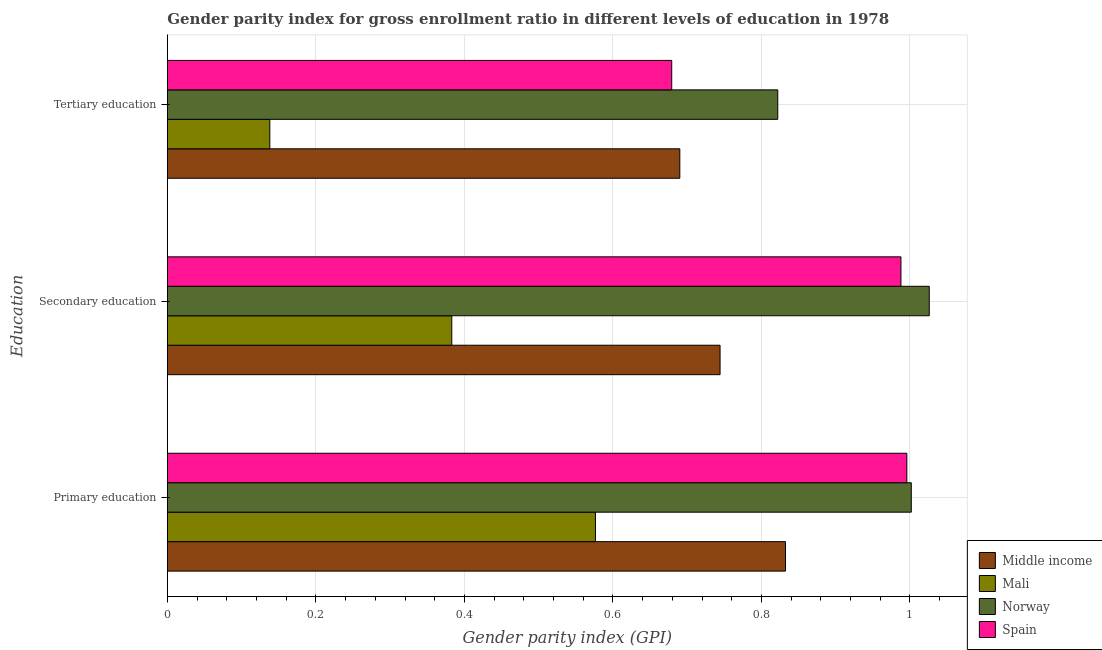How many different coloured bars are there?
Offer a very short reply. 4. Are the number of bars per tick equal to the number of legend labels?
Your answer should be compact. Yes. How many bars are there on the 3rd tick from the bottom?
Keep it short and to the point. 4. What is the label of the 3rd group of bars from the top?
Make the answer very short. Primary education. What is the gender parity index in primary education in Mali?
Your answer should be very brief. 0.58. Across all countries, what is the maximum gender parity index in tertiary education?
Your answer should be compact. 0.82. Across all countries, what is the minimum gender parity index in secondary education?
Ensure brevity in your answer.  0.38. In which country was the gender parity index in secondary education minimum?
Offer a terse response. Mali. What is the total gender parity index in secondary education in the graph?
Provide a short and direct response. 3.14. What is the difference between the gender parity index in primary education in Mali and that in Middle income?
Your answer should be very brief. -0.26. What is the difference between the gender parity index in tertiary education in Spain and the gender parity index in primary education in Middle income?
Offer a very short reply. -0.15. What is the average gender parity index in tertiary education per country?
Give a very brief answer. 0.58. What is the difference between the gender parity index in secondary education and gender parity index in tertiary education in Middle income?
Give a very brief answer. 0.05. What is the ratio of the gender parity index in secondary education in Spain to that in Middle income?
Your response must be concise. 1.33. Is the gender parity index in secondary education in Norway less than that in Middle income?
Provide a short and direct response. No. Is the difference between the gender parity index in secondary education in Middle income and Spain greater than the difference between the gender parity index in tertiary education in Middle income and Spain?
Offer a terse response. No. What is the difference between the highest and the second highest gender parity index in tertiary education?
Offer a very short reply. 0.13. What is the difference between the highest and the lowest gender parity index in primary education?
Provide a succinct answer. 0.43. In how many countries, is the gender parity index in secondary education greater than the average gender parity index in secondary education taken over all countries?
Give a very brief answer. 2. Is the sum of the gender parity index in primary education in Mali and Norway greater than the maximum gender parity index in secondary education across all countries?
Your answer should be very brief. Yes. What does the 1st bar from the bottom in Tertiary education represents?
Your answer should be very brief. Middle income. How many countries are there in the graph?
Your response must be concise. 4. Are the values on the major ticks of X-axis written in scientific E-notation?
Ensure brevity in your answer.  No. Does the graph contain any zero values?
Offer a terse response. No. How are the legend labels stacked?
Keep it short and to the point. Vertical. What is the title of the graph?
Offer a very short reply. Gender parity index for gross enrollment ratio in different levels of education in 1978. Does "American Samoa" appear as one of the legend labels in the graph?
Offer a very short reply. No. What is the label or title of the X-axis?
Provide a succinct answer. Gender parity index (GPI). What is the label or title of the Y-axis?
Provide a short and direct response. Education. What is the Gender parity index (GPI) in Middle income in Primary education?
Ensure brevity in your answer.  0.83. What is the Gender parity index (GPI) of Mali in Primary education?
Make the answer very short. 0.58. What is the Gender parity index (GPI) of Norway in Primary education?
Make the answer very short. 1. What is the Gender parity index (GPI) in Spain in Primary education?
Keep it short and to the point. 1. What is the Gender parity index (GPI) in Middle income in Secondary education?
Your response must be concise. 0.74. What is the Gender parity index (GPI) of Mali in Secondary education?
Provide a succinct answer. 0.38. What is the Gender parity index (GPI) in Norway in Secondary education?
Provide a short and direct response. 1.03. What is the Gender parity index (GPI) in Spain in Secondary education?
Offer a terse response. 0.99. What is the Gender parity index (GPI) of Middle income in Tertiary education?
Offer a very short reply. 0.69. What is the Gender parity index (GPI) of Mali in Tertiary education?
Your answer should be compact. 0.14. What is the Gender parity index (GPI) of Norway in Tertiary education?
Provide a short and direct response. 0.82. What is the Gender parity index (GPI) in Spain in Tertiary education?
Your answer should be very brief. 0.68. Across all Education, what is the maximum Gender parity index (GPI) in Middle income?
Offer a terse response. 0.83. Across all Education, what is the maximum Gender parity index (GPI) of Mali?
Offer a very short reply. 0.58. Across all Education, what is the maximum Gender parity index (GPI) in Norway?
Offer a terse response. 1.03. Across all Education, what is the maximum Gender parity index (GPI) of Spain?
Your answer should be compact. 1. Across all Education, what is the minimum Gender parity index (GPI) in Middle income?
Offer a terse response. 0.69. Across all Education, what is the minimum Gender parity index (GPI) of Mali?
Your answer should be compact. 0.14. Across all Education, what is the minimum Gender parity index (GPI) in Norway?
Provide a succinct answer. 0.82. Across all Education, what is the minimum Gender parity index (GPI) in Spain?
Make the answer very short. 0.68. What is the total Gender parity index (GPI) of Middle income in the graph?
Offer a very short reply. 2.27. What is the total Gender parity index (GPI) of Mali in the graph?
Provide a short and direct response. 1.1. What is the total Gender parity index (GPI) of Norway in the graph?
Offer a terse response. 2.85. What is the total Gender parity index (GPI) in Spain in the graph?
Your response must be concise. 2.66. What is the difference between the Gender parity index (GPI) in Middle income in Primary education and that in Secondary education?
Give a very brief answer. 0.09. What is the difference between the Gender parity index (GPI) in Mali in Primary education and that in Secondary education?
Your answer should be compact. 0.19. What is the difference between the Gender parity index (GPI) in Norway in Primary education and that in Secondary education?
Your response must be concise. -0.02. What is the difference between the Gender parity index (GPI) in Spain in Primary education and that in Secondary education?
Offer a terse response. 0.01. What is the difference between the Gender parity index (GPI) of Middle income in Primary education and that in Tertiary education?
Your response must be concise. 0.14. What is the difference between the Gender parity index (GPI) of Mali in Primary education and that in Tertiary education?
Offer a terse response. 0.44. What is the difference between the Gender parity index (GPI) of Norway in Primary education and that in Tertiary education?
Offer a very short reply. 0.18. What is the difference between the Gender parity index (GPI) of Spain in Primary education and that in Tertiary education?
Keep it short and to the point. 0.32. What is the difference between the Gender parity index (GPI) in Middle income in Secondary education and that in Tertiary education?
Offer a very short reply. 0.05. What is the difference between the Gender parity index (GPI) in Mali in Secondary education and that in Tertiary education?
Provide a succinct answer. 0.24. What is the difference between the Gender parity index (GPI) in Norway in Secondary education and that in Tertiary education?
Your response must be concise. 0.2. What is the difference between the Gender parity index (GPI) in Spain in Secondary education and that in Tertiary education?
Provide a short and direct response. 0.31. What is the difference between the Gender parity index (GPI) of Middle income in Primary education and the Gender parity index (GPI) of Mali in Secondary education?
Provide a short and direct response. 0.45. What is the difference between the Gender parity index (GPI) of Middle income in Primary education and the Gender parity index (GPI) of Norway in Secondary education?
Ensure brevity in your answer.  -0.19. What is the difference between the Gender parity index (GPI) of Middle income in Primary education and the Gender parity index (GPI) of Spain in Secondary education?
Give a very brief answer. -0.16. What is the difference between the Gender parity index (GPI) in Mali in Primary education and the Gender parity index (GPI) in Norway in Secondary education?
Offer a very short reply. -0.45. What is the difference between the Gender parity index (GPI) in Mali in Primary education and the Gender parity index (GPI) in Spain in Secondary education?
Your response must be concise. -0.41. What is the difference between the Gender parity index (GPI) in Norway in Primary education and the Gender parity index (GPI) in Spain in Secondary education?
Your answer should be compact. 0.01. What is the difference between the Gender parity index (GPI) of Middle income in Primary education and the Gender parity index (GPI) of Mali in Tertiary education?
Offer a very short reply. 0.69. What is the difference between the Gender parity index (GPI) of Middle income in Primary education and the Gender parity index (GPI) of Norway in Tertiary education?
Offer a terse response. 0.01. What is the difference between the Gender parity index (GPI) of Middle income in Primary education and the Gender parity index (GPI) of Spain in Tertiary education?
Your answer should be very brief. 0.15. What is the difference between the Gender parity index (GPI) of Mali in Primary education and the Gender parity index (GPI) of Norway in Tertiary education?
Make the answer very short. -0.25. What is the difference between the Gender parity index (GPI) in Mali in Primary education and the Gender parity index (GPI) in Spain in Tertiary education?
Ensure brevity in your answer.  -0.1. What is the difference between the Gender parity index (GPI) in Norway in Primary education and the Gender parity index (GPI) in Spain in Tertiary education?
Keep it short and to the point. 0.32. What is the difference between the Gender parity index (GPI) in Middle income in Secondary education and the Gender parity index (GPI) in Mali in Tertiary education?
Give a very brief answer. 0.61. What is the difference between the Gender parity index (GPI) in Middle income in Secondary education and the Gender parity index (GPI) in Norway in Tertiary education?
Offer a very short reply. -0.08. What is the difference between the Gender parity index (GPI) in Middle income in Secondary education and the Gender parity index (GPI) in Spain in Tertiary education?
Give a very brief answer. 0.07. What is the difference between the Gender parity index (GPI) of Mali in Secondary education and the Gender parity index (GPI) of Norway in Tertiary education?
Give a very brief answer. -0.44. What is the difference between the Gender parity index (GPI) of Mali in Secondary education and the Gender parity index (GPI) of Spain in Tertiary education?
Offer a very short reply. -0.3. What is the difference between the Gender parity index (GPI) of Norway in Secondary education and the Gender parity index (GPI) of Spain in Tertiary education?
Offer a terse response. 0.35. What is the average Gender parity index (GPI) in Middle income per Education?
Offer a terse response. 0.76. What is the average Gender parity index (GPI) in Mali per Education?
Make the answer very short. 0.37. What is the average Gender parity index (GPI) of Norway per Education?
Ensure brevity in your answer.  0.95. What is the average Gender parity index (GPI) in Spain per Education?
Your answer should be compact. 0.89. What is the difference between the Gender parity index (GPI) in Middle income and Gender parity index (GPI) in Mali in Primary education?
Your answer should be compact. 0.26. What is the difference between the Gender parity index (GPI) in Middle income and Gender parity index (GPI) in Norway in Primary education?
Your answer should be very brief. -0.17. What is the difference between the Gender parity index (GPI) in Middle income and Gender parity index (GPI) in Spain in Primary education?
Keep it short and to the point. -0.16. What is the difference between the Gender parity index (GPI) of Mali and Gender parity index (GPI) of Norway in Primary education?
Offer a terse response. -0.43. What is the difference between the Gender parity index (GPI) in Mali and Gender parity index (GPI) in Spain in Primary education?
Provide a short and direct response. -0.42. What is the difference between the Gender parity index (GPI) in Norway and Gender parity index (GPI) in Spain in Primary education?
Make the answer very short. 0.01. What is the difference between the Gender parity index (GPI) in Middle income and Gender parity index (GPI) in Mali in Secondary education?
Your answer should be compact. 0.36. What is the difference between the Gender parity index (GPI) of Middle income and Gender parity index (GPI) of Norway in Secondary education?
Your answer should be very brief. -0.28. What is the difference between the Gender parity index (GPI) of Middle income and Gender parity index (GPI) of Spain in Secondary education?
Your answer should be compact. -0.24. What is the difference between the Gender parity index (GPI) in Mali and Gender parity index (GPI) in Norway in Secondary education?
Your answer should be compact. -0.64. What is the difference between the Gender parity index (GPI) of Mali and Gender parity index (GPI) of Spain in Secondary education?
Your answer should be compact. -0.6. What is the difference between the Gender parity index (GPI) of Norway and Gender parity index (GPI) of Spain in Secondary education?
Provide a succinct answer. 0.04. What is the difference between the Gender parity index (GPI) of Middle income and Gender parity index (GPI) of Mali in Tertiary education?
Keep it short and to the point. 0.55. What is the difference between the Gender parity index (GPI) in Middle income and Gender parity index (GPI) in Norway in Tertiary education?
Provide a short and direct response. -0.13. What is the difference between the Gender parity index (GPI) in Middle income and Gender parity index (GPI) in Spain in Tertiary education?
Your answer should be very brief. 0.01. What is the difference between the Gender parity index (GPI) in Mali and Gender parity index (GPI) in Norway in Tertiary education?
Ensure brevity in your answer.  -0.68. What is the difference between the Gender parity index (GPI) of Mali and Gender parity index (GPI) of Spain in Tertiary education?
Your answer should be very brief. -0.54. What is the difference between the Gender parity index (GPI) of Norway and Gender parity index (GPI) of Spain in Tertiary education?
Provide a short and direct response. 0.14. What is the ratio of the Gender parity index (GPI) of Middle income in Primary education to that in Secondary education?
Offer a very short reply. 1.12. What is the ratio of the Gender parity index (GPI) in Mali in Primary education to that in Secondary education?
Offer a terse response. 1.51. What is the ratio of the Gender parity index (GPI) in Norway in Primary education to that in Secondary education?
Keep it short and to the point. 0.98. What is the ratio of the Gender parity index (GPI) in Spain in Primary education to that in Secondary education?
Offer a very short reply. 1.01. What is the ratio of the Gender parity index (GPI) in Middle income in Primary education to that in Tertiary education?
Give a very brief answer. 1.21. What is the ratio of the Gender parity index (GPI) of Mali in Primary education to that in Tertiary education?
Your answer should be compact. 4.18. What is the ratio of the Gender parity index (GPI) in Norway in Primary education to that in Tertiary education?
Make the answer very short. 1.22. What is the ratio of the Gender parity index (GPI) in Spain in Primary education to that in Tertiary education?
Your answer should be compact. 1.47. What is the ratio of the Gender parity index (GPI) of Middle income in Secondary education to that in Tertiary education?
Offer a very short reply. 1.08. What is the ratio of the Gender parity index (GPI) in Mali in Secondary education to that in Tertiary education?
Make the answer very short. 2.78. What is the ratio of the Gender parity index (GPI) in Norway in Secondary education to that in Tertiary education?
Provide a succinct answer. 1.25. What is the ratio of the Gender parity index (GPI) of Spain in Secondary education to that in Tertiary education?
Provide a short and direct response. 1.45. What is the difference between the highest and the second highest Gender parity index (GPI) in Middle income?
Ensure brevity in your answer.  0.09. What is the difference between the highest and the second highest Gender parity index (GPI) in Mali?
Provide a short and direct response. 0.19. What is the difference between the highest and the second highest Gender parity index (GPI) in Norway?
Offer a very short reply. 0.02. What is the difference between the highest and the second highest Gender parity index (GPI) of Spain?
Provide a short and direct response. 0.01. What is the difference between the highest and the lowest Gender parity index (GPI) of Middle income?
Make the answer very short. 0.14. What is the difference between the highest and the lowest Gender parity index (GPI) of Mali?
Ensure brevity in your answer.  0.44. What is the difference between the highest and the lowest Gender parity index (GPI) in Norway?
Your answer should be compact. 0.2. What is the difference between the highest and the lowest Gender parity index (GPI) in Spain?
Your answer should be very brief. 0.32. 